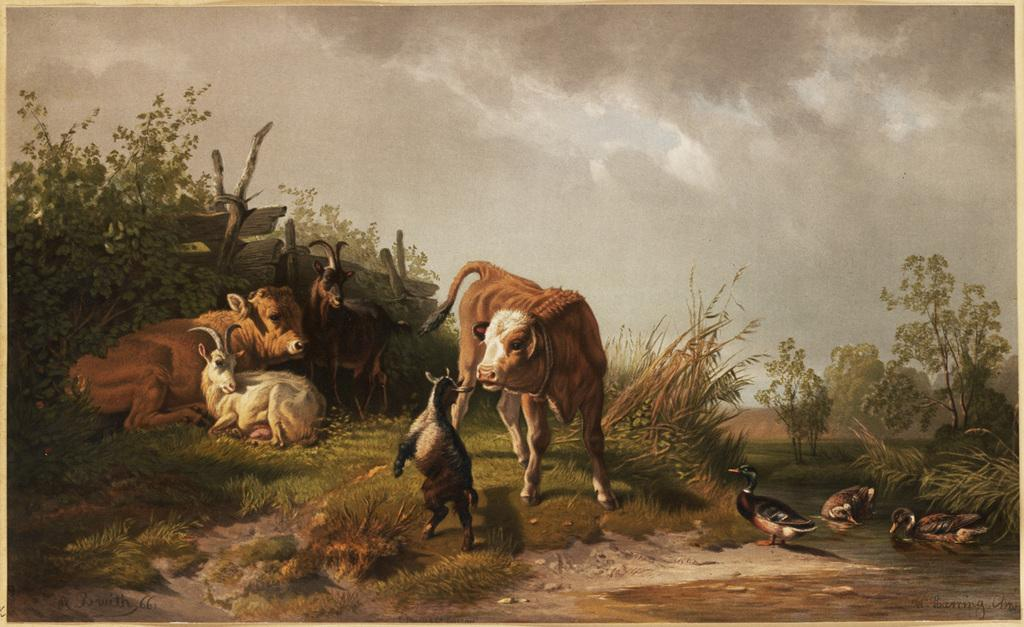What type of living organisms can be seen in the image? There are animals in the image. What colors are the animals in the image? The animals are in brown, black, and white colors. Which specific animals can be identified in the image? There are ducks in the image. What type of natural environment is visible in the image? There are trees, grass, and wooden logs in the image. What is the color of the sky in the image? The sky is in white and ash colors. What type of plant is growing inside the duck's stomach in the image? There is no plant growing inside the duck's stomach in the image, as ducks do not have plants growing inside them. 